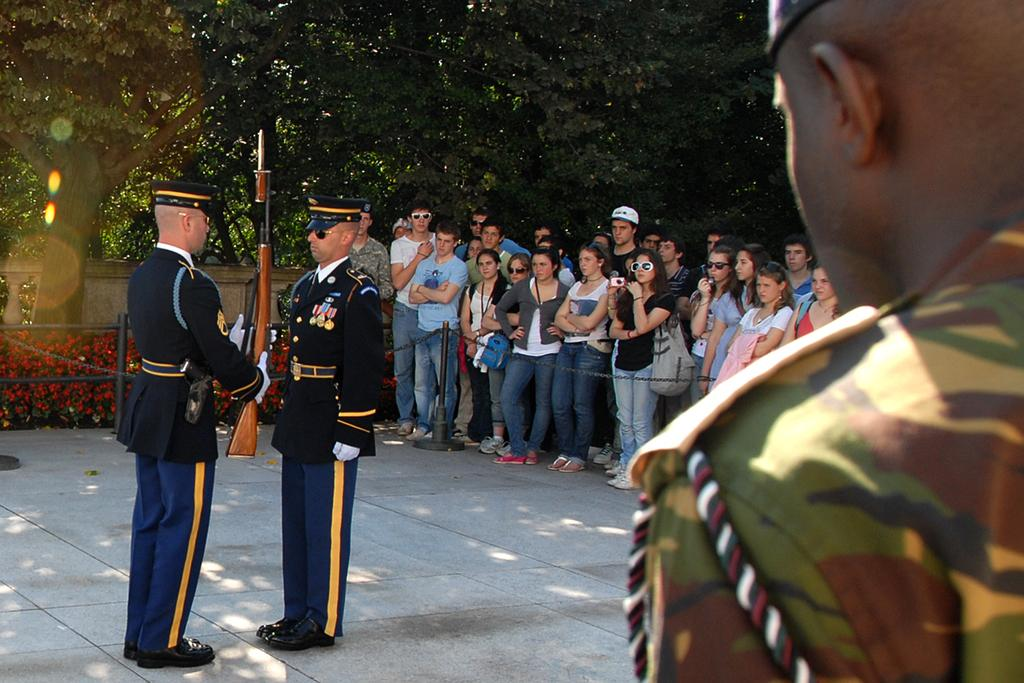What are the people in the image doing? The people in the image are standing and holding rifles in their hands. Are there any other people visible in the image? Yes, there are other people standing behind them. What can be seen in the background of the image? Many trees are visible in the background. What type of chin can be seen on the trees in the background? There are no chins present in the image, as it features people holding rifles and trees in the background. 